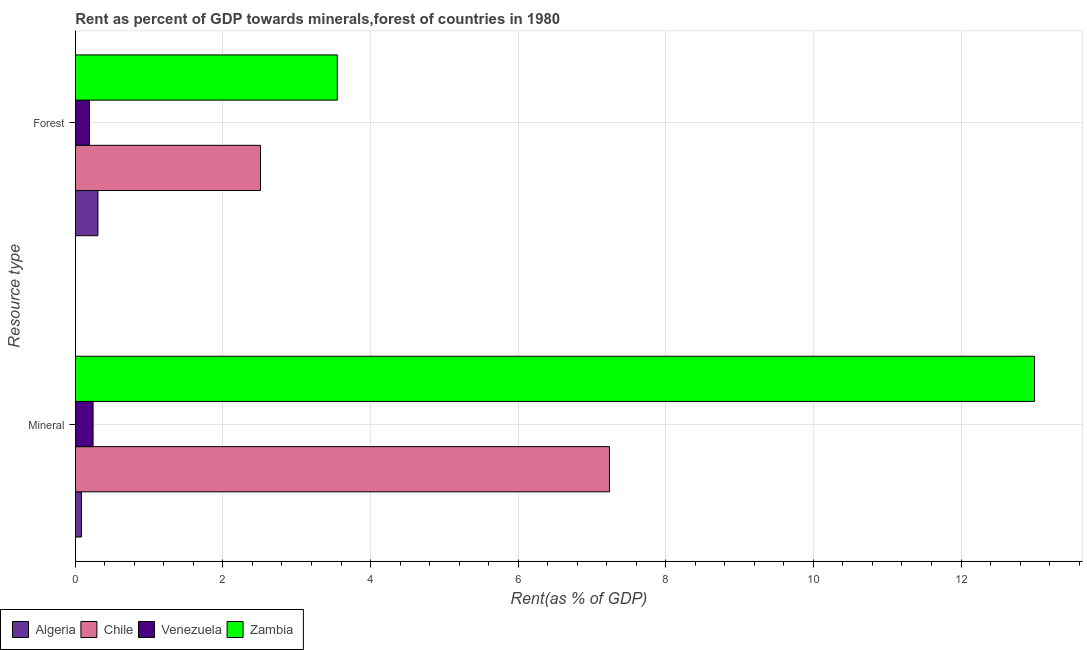Are the number of bars per tick equal to the number of legend labels?
Give a very brief answer. Yes. How many bars are there on the 2nd tick from the top?
Keep it short and to the point. 4. How many bars are there on the 1st tick from the bottom?
Offer a terse response. 4. What is the label of the 1st group of bars from the top?
Keep it short and to the point. Forest. What is the forest rent in Venezuela?
Provide a succinct answer. 0.19. Across all countries, what is the maximum forest rent?
Provide a short and direct response. 3.55. Across all countries, what is the minimum mineral rent?
Your response must be concise. 0.08. In which country was the forest rent maximum?
Provide a short and direct response. Zambia. In which country was the mineral rent minimum?
Provide a succinct answer. Algeria. What is the total forest rent in the graph?
Your answer should be very brief. 6.56. What is the difference between the mineral rent in Venezuela and that in Chile?
Provide a succinct answer. -7. What is the difference between the forest rent in Zambia and the mineral rent in Venezuela?
Provide a short and direct response. 3.31. What is the average forest rent per country?
Keep it short and to the point. 1.64. What is the difference between the forest rent and mineral rent in Algeria?
Provide a short and direct response. 0.22. In how many countries, is the mineral rent greater than 12.8 %?
Offer a terse response. 1. What is the ratio of the forest rent in Algeria to that in Zambia?
Your answer should be compact. 0.09. Is the mineral rent in Chile less than that in Algeria?
Provide a succinct answer. No. What does the 4th bar from the top in Forest represents?
Your response must be concise. Algeria. What does the 1st bar from the bottom in Forest represents?
Give a very brief answer. Algeria. Are all the bars in the graph horizontal?
Your answer should be very brief. Yes. Are the values on the major ticks of X-axis written in scientific E-notation?
Give a very brief answer. No. Where does the legend appear in the graph?
Your response must be concise. Bottom left. How are the legend labels stacked?
Offer a terse response. Horizontal. What is the title of the graph?
Give a very brief answer. Rent as percent of GDP towards minerals,forest of countries in 1980. What is the label or title of the X-axis?
Make the answer very short. Rent(as % of GDP). What is the label or title of the Y-axis?
Give a very brief answer. Resource type. What is the Rent(as % of GDP) in Algeria in Mineral?
Your answer should be very brief. 0.08. What is the Rent(as % of GDP) of Chile in Mineral?
Keep it short and to the point. 7.24. What is the Rent(as % of GDP) in Venezuela in Mineral?
Your answer should be compact. 0.24. What is the Rent(as % of GDP) in Zambia in Mineral?
Offer a terse response. 13. What is the Rent(as % of GDP) in Algeria in Forest?
Give a very brief answer. 0.31. What is the Rent(as % of GDP) of Chile in Forest?
Make the answer very short. 2.51. What is the Rent(as % of GDP) in Venezuela in Forest?
Provide a succinct answer. 0.19. What is the Rent(as % of GDP) of Zambia in Forest?
Keep it short and to the point. 3.55. Across all Resource type, what is the maximum Rent(as % of GDP) of Algeria?
Keep it short and to the point. 0.31. Across all Resource type, what is the maximum Rent(as % of GDP) of Chile?
Your answer should be compact. 7.24. Across all Resource type, what is the maximum Rent(as % of GDP) in Venezuela?
Provide a short and direct response. 0.24. Across all Resource type, what is the maximum Rent(as % of GDP) of Zambia?
Offer a very short reply. 13. Across all Resource type, what is the minimum Rent(as % of GDP) of Algeria?
Provide a short and direct response. 0.08. Across all Resource type, what is the minimum Rent(as % of GDP) in Chile?
Make the answer very short. 2.51. Across all Resource type, what is the minimum Rent(as % of GDP) in Venezuela?
Give a very brief answer. 0.19. Across all Resource type, what is the minimum Rent(as % of GDP) in Zambia?
Offer a very short reply. 3.55. What is the total Rent(as % of GDP) of Algeria in the graph?
Provide a short and direct response. 0.39. What is the total Rent(as % of GDP) of Chile in the graph?
Your answer should be very brief. 9.75. What is the total Rent(as % of GDP) in Venezuela in the graph?
Provide a succinct answer. 0.43. What is the total Rent(as % of GDP) of Zambia in the graph?
Give a very brief answer. 16.55. What is the difference between the Rent(as % of GDP) in Algeria in Mineral and that in Forest?
Keep it short and to the point. -0.22. What is the difference between the Rent(as % of GDP) of Chile in Mineral and that in Forest?
Ensure brevity in your answer.  4.73. What is the difference between the Rent(as % of GDP) of Venezuela in Mineral and that in Forest?
Offer a very short reply. 0.05. What is the difference between the Rent(as % of GDP) in Zambia in Mineral and that in Forest?
Your response must be concise. 9.45. What is the difference between the Rent(as % of GDP) of Algeria in Mineral and the Rent(as % of GDP) of Chile in Forest?
Provide a short and direct response. -2.43. What is the difference between the Rent(as % of GDP) in Algeria in Mineral and the Rent(as % of GDP) in Venezuela in Forest?
Keep it short and to the point. -0.11. What is the difference between the Rent(as % of GDP) in Algeria in Mineral and the Rent(as % of GDP) in Zambia in Forest?
Offer a very short reply. -3.47. What is the difference between the Rent(as % of GDP) in Chile in Mineral and the Rent(as % of GDP) in Venezuela in Forest?
Ensure brevity in your answer.  7.04. What is the difference between the Rent(as % of GDP) in Chile in Mineral and the Rent(as % of GDP) in Zambia in Forest?
Your answer should be compact. 3.69. What is the difference between the Rent(as % of GDP) of Venezuela in Mineral and the Rent(as % of GDP) of Zambia in Forest?
Provide a short and direct response. -3.31. What is the average Rent(as % of GDP) in Algeria per Resource type?
Provide a short and direct response. 0.19. What is the average Rent(as % of GDP) of Chile per Resource type?
Keep it short and to the point. 4.87. What is the average Rent(as % of GDP) in Venezuela per Resource type?
Your answer should be compact. 0.22. What is the average Rent(as % of GDP) of Zambia per Resource type?
Provide a succinct answer. 8.27. What is the difference between the Rent(as % of GDP) in Algeria and Rent(as % of GDP) in Chile in Mineral?
Keep it short and to the point. -7.15. What is the difference between the Rent(as % of GDP) in Algeria and Rent(as % of GDP) in Venezuela in Mineral?
Give a very brief answer. -0.16. What is the difference between the Rent(as % of GDP) in Algeria and Rent(as % of GDP) in Zambia in Mineral?
Offer a terse response. -12.91. What is the difference between the Rent(as % of GDP) in Chile and Rent(as % of GDP) in Venezuela in Mineral?
Make the answer very short. 7. What is the difference between the Rent(as % of GDP) in Chile and Rent(as % of GDP) in Zambia in Mineral?
Offer a very short reply. -5.76. What is the difference between the Rent(as % of GDP) of Venezuela and Rent(as % of GDP) of Zambia in Mineral?
Give a very brief answer. -12.76. What is the difference between the Rent(as % of GDP) of Algeria and Rent(as % of GDP) of Chile in Forest?
Ensure brevity in your answer.  -2.2. What is the difference between the Rent(as % of GDP) in Algeria and Rent(as % of GDP) in Venezuela in Forest?
Offer a very short reply. 0.11. What is the difference between the Rent(as % of GDP) in Algeria and Rent(as % of GDP) in Zambia in Forest?
Your answer should be compact. -3.24. What is the difference between the Rent(as % of GDP) in Chile and Rent(as % of GDP) in Venezuela in Forest?
Give a very brief answer. 2.32. What is the difference between the Rent(as % of GDP) of Chile and Rent(as % of GDP) of Zambia in Forest?
Offer a very short reply. -1.04. What is the difference between the Rent(as % of GDP) in Venezuela and Rent(as % of GDP) in Zambia in Forest?
Offer a terse response. -3.36. What is the ratio of the Rent(as % of GDP) of Algeria in Mineral to that in Forest?
Make the answer very short. 0.27. What is the ratio of the Rent(as % of GDP) in Chile in Mineral to that in Forest?
Your response must be concise. 2.88. What is the ratio of the Rent(as % of GDP) in Venezuela in Mineral to that in Forest?
Your response must be concise. 1.25. What is the ratio of the Rent(as % of GDP) in Zambia in Mineral to that in Forest?
Your answer should be compact. 3.66. What is the difference between the highest and the second highest Rent(as % of GDP) of Algeria?
Make the answer very short. 0.22. What is the difference between the highest and the second highest Rent(as % of GDP) in Chile?
Keep it short and to the point. 4.73. What is the difference between the highest and the second highest Rent(as % of GDP) in Venezuela?
Ensure brevity in your answer.  0.05. What is the difference between the highest and the second highest Rent(as % of GDP) of Zambia?
Provide a short and direct response. 9.45. What is the difference between the highest and the lowest Rent(as % of GDP) of Algeria?
Your answer should be compact. 0.22. What is the difference between the highest and the lowest Rent(as % of GDP) in Chile?
Make the answer very short. 4.73. What is the difference between the highest and the lowest Rent(as % of GDP) in Venezuela?
Give a very brief answer. 0.05. What is the difference between the highest and the lowest Rent(as % of GDP) of Zambia?
Your answer should be compact. 9.45. 